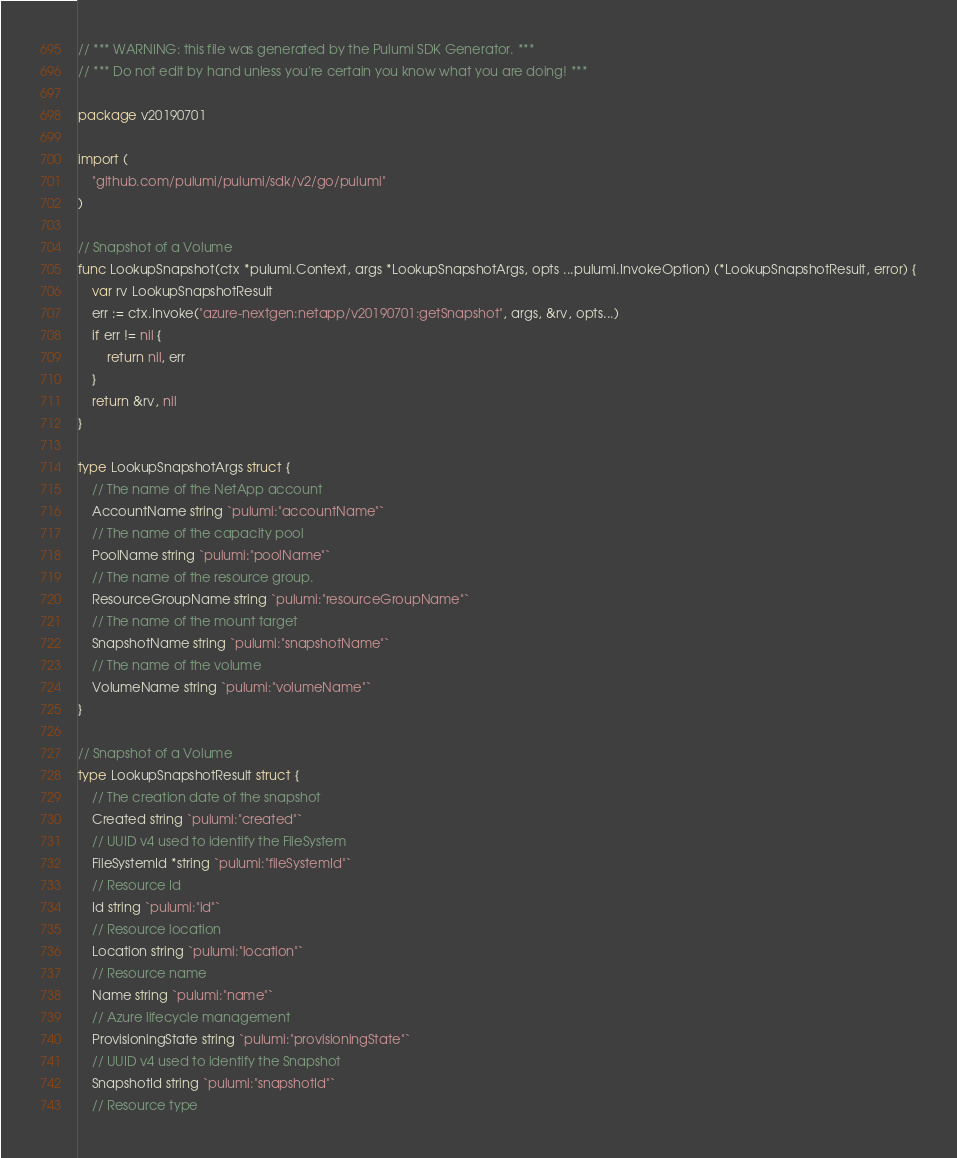<code> <loc_0><loc_0><loc_500><loc_500><_Go_>// *** WARNING: this file was generated by the Pulumi SDK Generator. ***
// *** Do not edit by hand unless you're certain you know what you are doing! ***

package v20190701

import (
	"github.com/pulumi/pulumi/sdk/v2/go/pulumi"
)

// Snapshot of a Volume
func LookupSnapshot(ctx *pulumi.Context, args *LookupSnapshotArgs, opts ...pulumi.InvokeOption) (*LookupSnapshotResult, error) {
	var rv LookupSnapshotResult
	err := ctx.Invoke("azure-nextgen:netapp/v20190701:getSnapshot", args, &rv, opts...)
	if err != nil {
		return nil, err
	}
	return &rv, nil
}

type LookupSnapshotArgs struct {
	// The name of the NetApp account
	AccountName string `pulumi:"accountName"`
	// The name of the capacity pool
	PoolName string `pulumi:"poolName"`
	// The name of the resource group.
	ResourceGroupName string `pulumi:"resourceGroupName"`
	// The name of the mount target
	SnapshotName string `pulumi:"snapshotName"`
	// The name of the volume
	VolumeName string `pulumi:"volumeName"`
}

// Snapshot of a Volume
type LookupSnapshotResult struct {
	// The creation date of the snapshot
	Created string `pulumi:"created"`
	// UUID v4 used to identify the FileSystem
	FileSystemId *string `pulumi:"fileSystemId"`
	// Resource Id
	Id string `pulumi:"id"`
	// Resource location
	Location string `pulumi:"location"`
	// Resource name
	Name string `pulumi:"name"`
	// Azure lifecycle management
	ProvisioningState string `pulumi:"provisioningState"`
	// UUID v4 used to identify the Snapshot
	SnapshotId string `pulumi:"snapshotId"`
	// Resource type</code> 